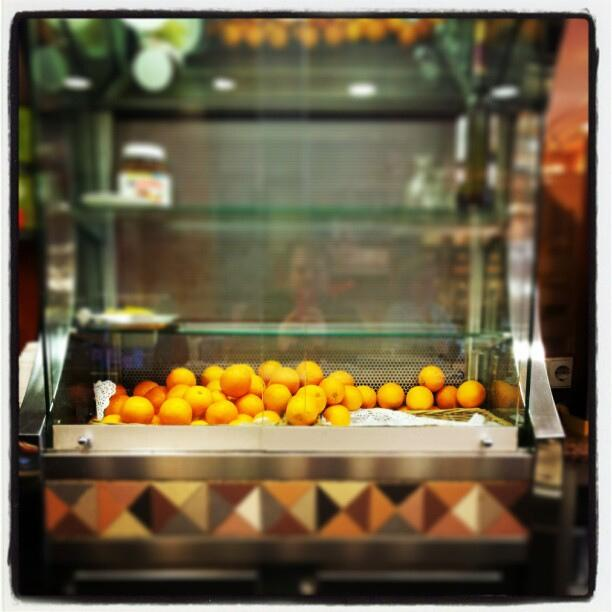What vitamin does this fruit contain the most? vitamin c 